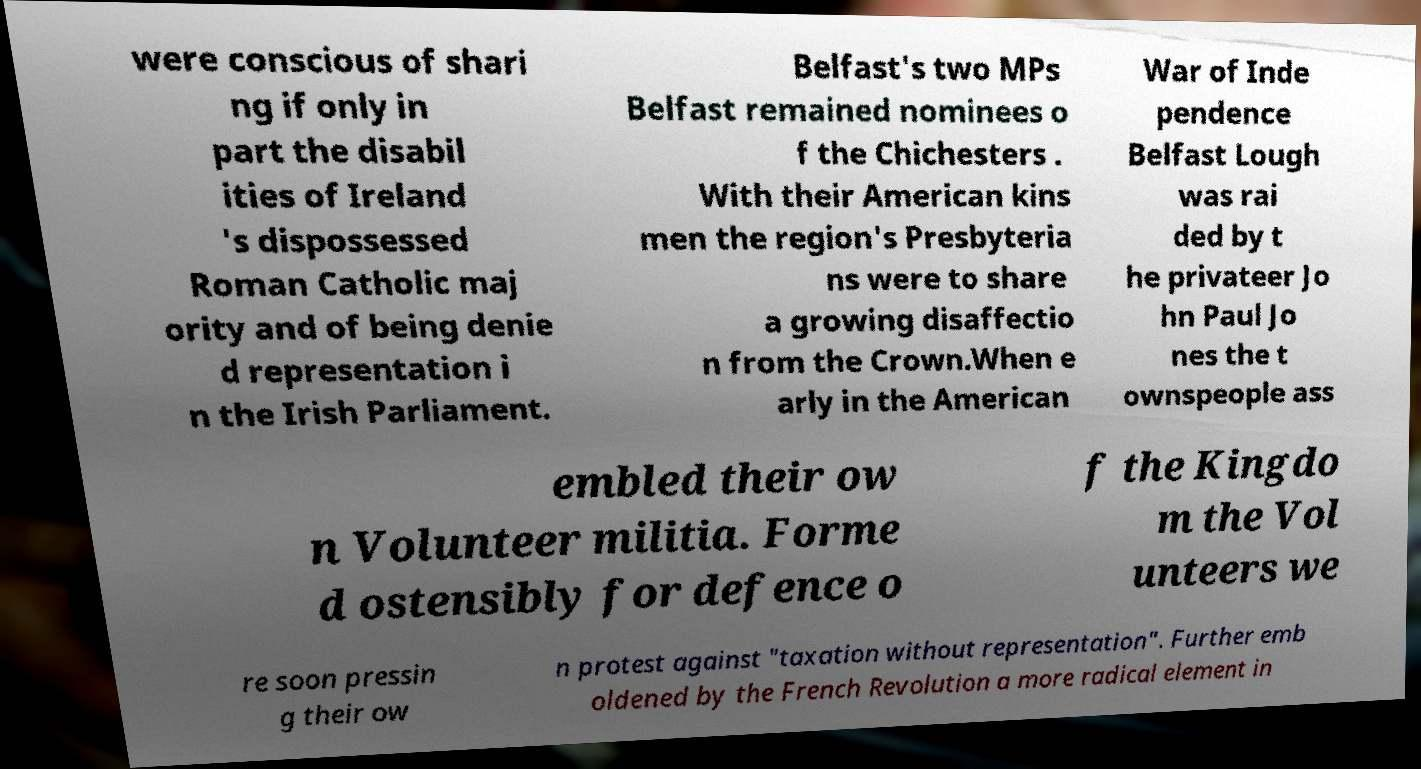Please read and relay the text visible in this image. What does it say? were conscious of shari ng if only in part the disabil ities of Ireland 's dispossessed Roman Catholic maj ority and of being denie d representation i n the Irish Parliament. Belfast's two MPs Belfast remained nominees o f the Chichesters . With their American kins men the region's Presbyteria ns were to share a growing disaffectio n from the Crown.When e arly in the American War of Inde pendence Belfast Lough was rai ded by t he privateer Jo hn Paul Jo nes the t ownspeople ass embled their ow n Volunteer militia. Forme d ostensibly for defence o f the Kingdo m the Vol unteers we re soon pressin g their ow n protest against "taxation without representation". Further emb oldened by the French Revolution a more radical element in 